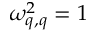Convert formula to latex. <formula><loc_0><loc_0><loc_500><loc_500>\omega _ { q , q } ^ { 2 } = 1</formula> 